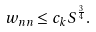Convert formula to latex. <formula><loc_0><loc_0><loc_500><loc_500>w _ { n n } \leq c _ { k } S ^ { \frac { 3 } { 4 } } .</formula> 